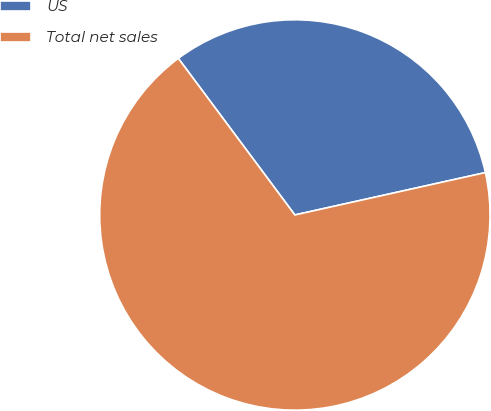Convert chart. <chart><loc_0><loc_0><loc_500><loc_500><pie_chart><fcel>US<fcel>Total net sales<nl><fcel>31.7%<fcel>68.3%<nl></chart> 